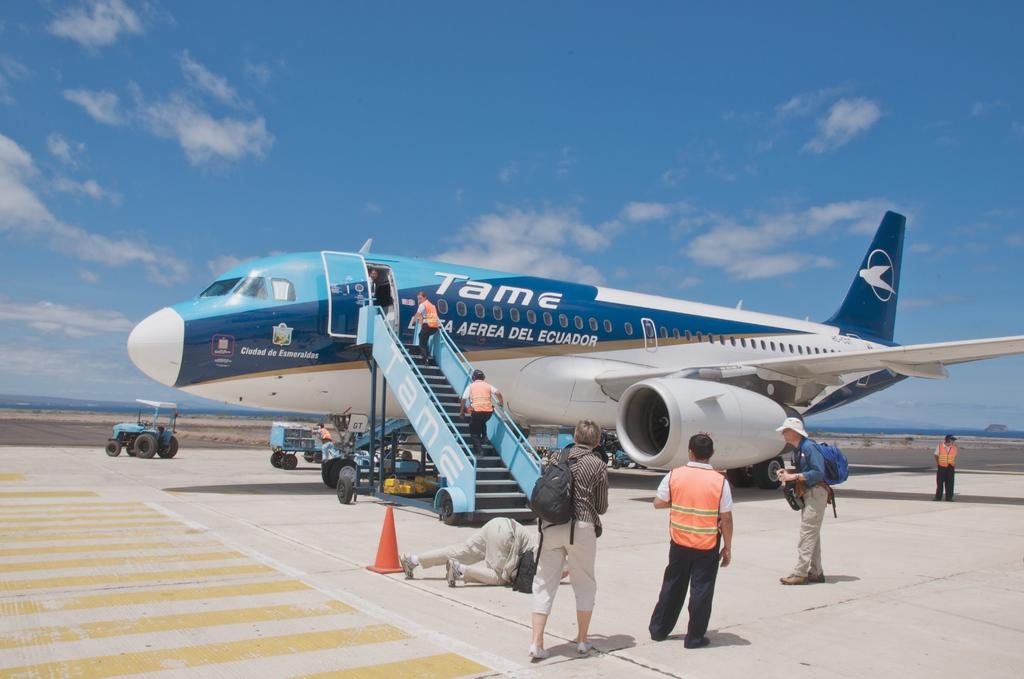What is the airline that the plane belongs to?
Provide a succinct answer. Tame. What is the name of the country on the plane?
Your answer should be very brief. Ecuador. 